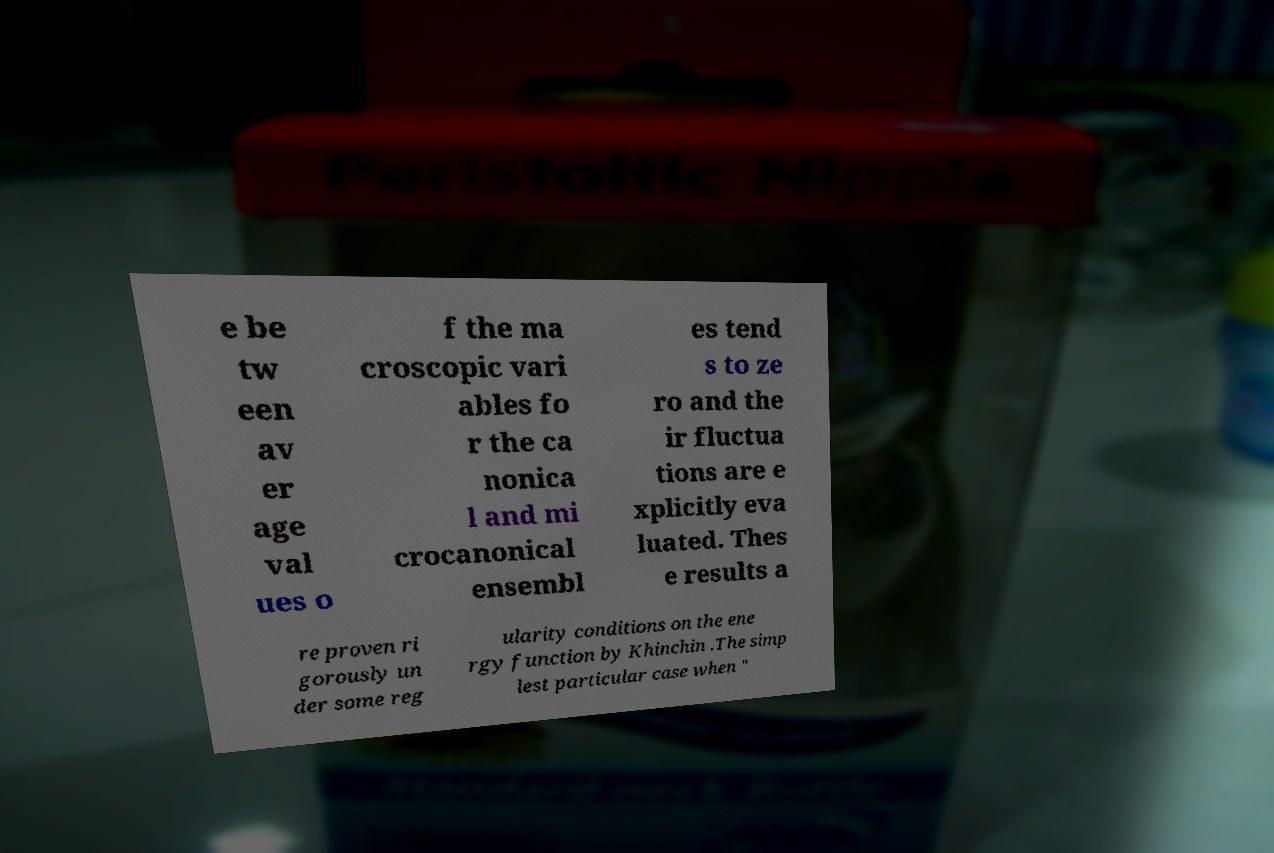There's text embedded in this image that I need extracted. Can you transcribe it verbatim? e be tw een av er age val ues o f the ma croscopic vari ables fo r the ca nonica l and mi crocanonical ensembl es tend s to ze ro and the ir fluctua tions are e xplicitly eva luated. Thes e results a re proven ri gorously un der some reg ularity conditions on the ene rgy function by Khinchin .The simp lest particular case when " 